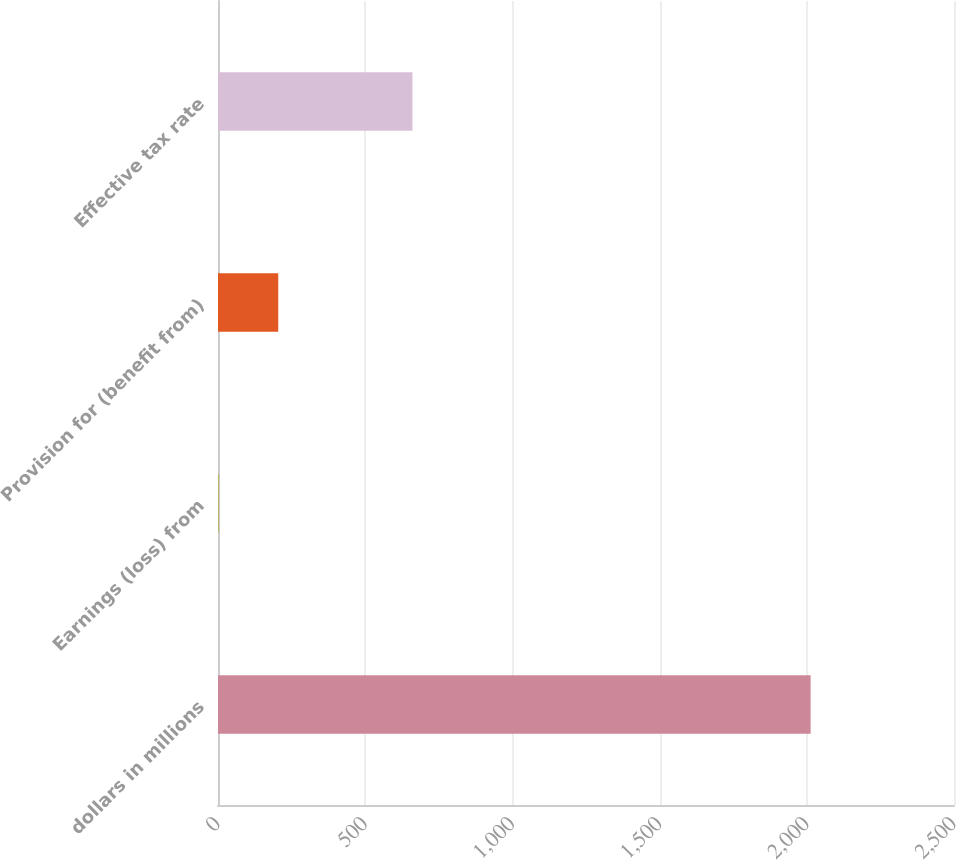Convert chart to OTSL. <chart><loc_0><loc_0><loc_500><loc_500><bar_chart><fcel>dollars in millions<fcel>Earnings (loss) from<fcel>Provision for (benefit from)<fcel>Effective tax rate<nl><fcel>2013<fcel>3.7<fcel>204.63<fcel>660.5<nl></chart> 